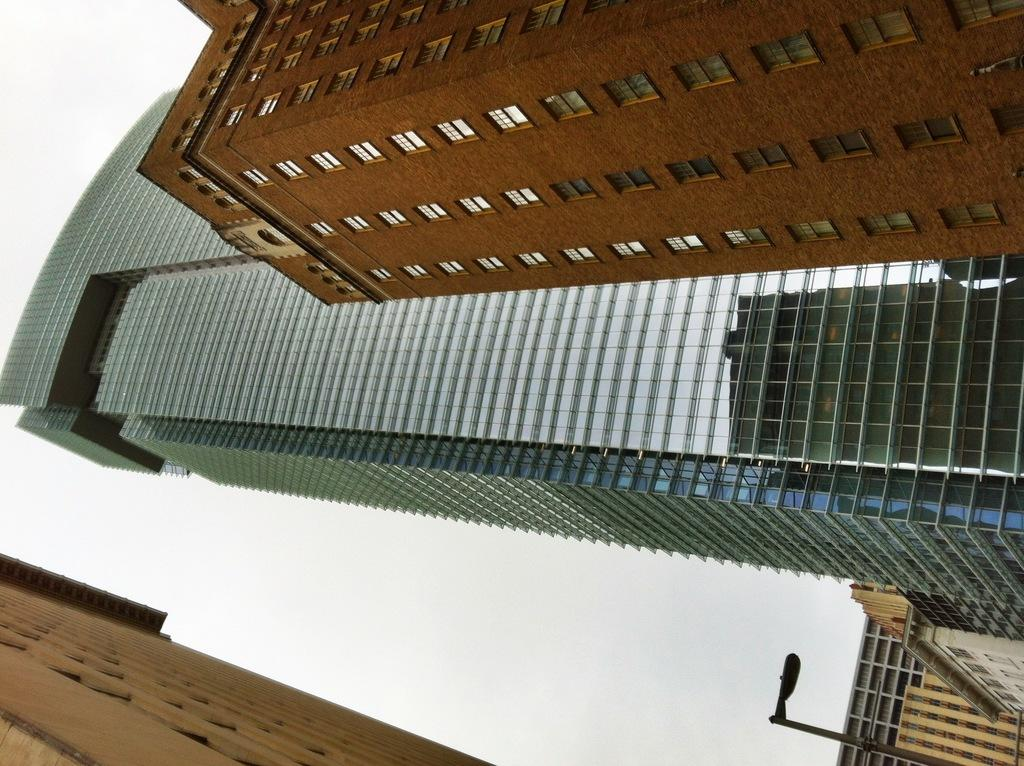What type of structures are present in the image? There is a group of buildings in the image. What feature do the buildings have? The buildings have windows. What other object can be seen in the image? There is a street pole in the image. What is visible in the background of the image? The sky is visible in the image. How would you describe the sky in the image? The sky looks cloudy. How many rings are visible on the island in the image? There is no island present in the image, and therefore no rings can be observed. 